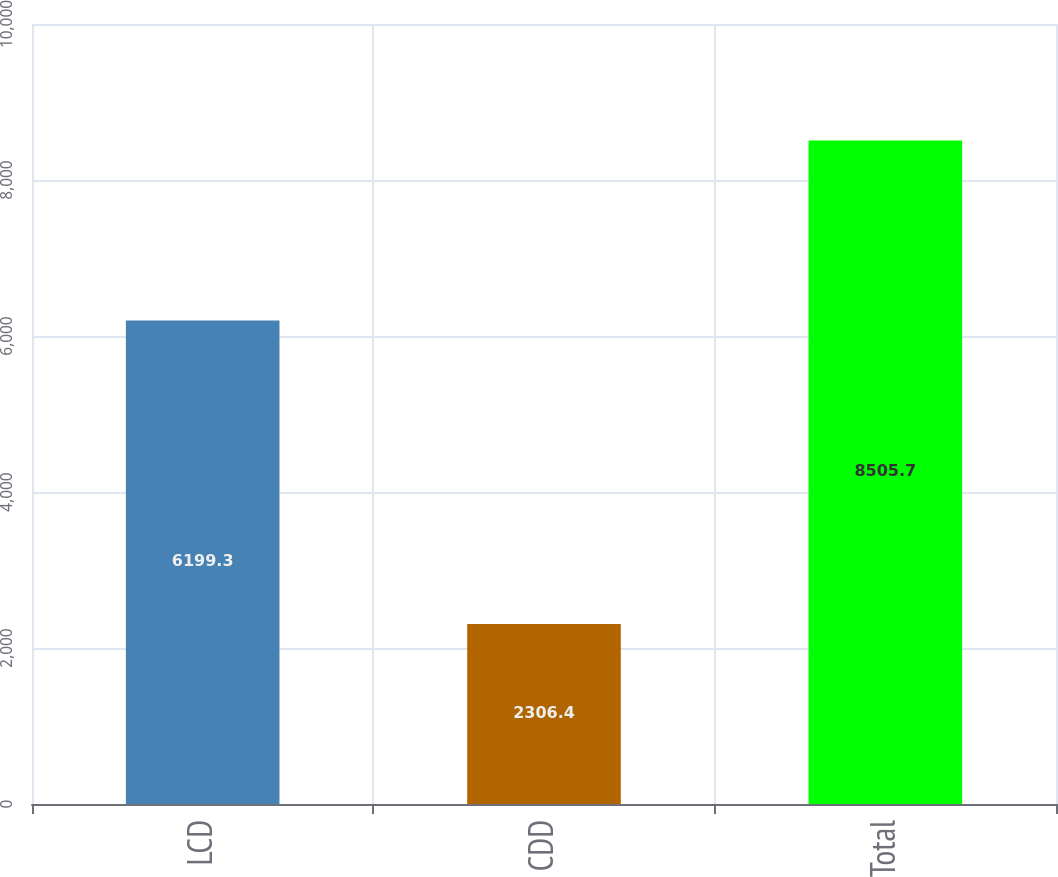Convert chart. <chart><loc_0><loc_0><loc_500><loc_500><bar_chart><fcel>LCD<fcel>CDD<fcel>Total<nl><fcel>6199.3<fcel>2306.4<fcel>8505.7<nl></chart> 